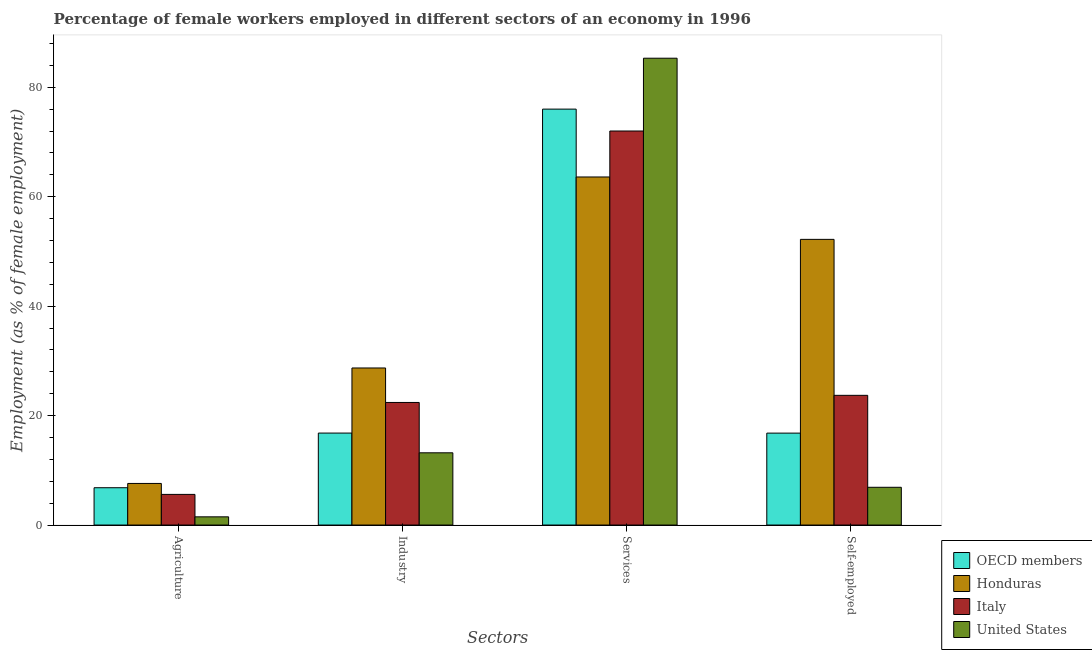Are the number of bars per tick equal to the number of legend labels?
Your answer should be very brief. Yes. How many bars are there on the 1st tick from the left?
Keep it short and to the point. 4. How many bars are there on the 1st tick from the right?
Provide a short and direct response. 4. What is the label of the 4th group of bars from the left?
Keep it short and to the point. Self-employed. What is the percentage of female workers in industry in Italy?
Offer a very short reply. 22.4. Across all countries, what is the maximum percentage of female workers in services?
Keep it short and to the point. 85.3. Across all countries, what is the minimum percentage of female workers in agriculture?
Your response must be concise. 1.5. In which country was the percentage of female workers in industry maximum?
Ensure brevity in your answer.  Honduras. What is the total percentage of female workers in industry in the graph?
Your answer should be compact. 81.1. What is the difference between the percentage of female workers in services in United States and that in Italy?
Offer a very short reply. 13.3. What is the difference between the percentage of female workers in services in Italy and the percentage of female workers in agriculture in OECD members?
Make the answer very short. 65.18. What is the average percentage of self employed female workers per country?
Your response must be concise. 24.9. What is the difference between the percentage of female workers in agriculture and percentage of female workers in industry in Honduras?
Your response must be concise. -21.1. What is the ratio of the percentage of female workers in services in Honduras to that in United States?
Your answer should be compact. 0.75. Is the percentage of self employed female workers in Italy less than that in Honduras?
Ensure brevity in your answer.  Yes. Is the difference between the percentage of female workers in industry in Honduras and United States greater than the difference between the percentage of female workers in agriculture in Honduras and United States?
Your answer should be very brief. Yes. What is the difference between the highest and the second highest percentage of female workers in agriculture?
Provide a succinct answer. 0.78. What is the difference between the highest and the lowest percentage of female workers in agriculture?
Give a very brief answer. 6.1. In how many countries, is the percentage of female workers in services greater than the average percentage of female workers in services taken over all countries?
Provide a succinct answer. 2. Is the sum of the percentage of female workers in services in Italy and Honduras greater than the maximum percentage of self employed female workers across all countries?
Your answer should be compact. Yes. Is it the case that in every country, the sum of the percentage of female workers in agriculture and percentage of female workers in industry is greater than the sum of percentage of self employed female workers and percentage of female workers in services?
Make the answer very short. Yes. What does the 3rd bar from the right in Agriculture represents?
Keep it short and to the point. Honduras. Are all the bars in the graph horizontal?
Your answer should be very brief. No. What is the difference between two consecutive major ticks on the Y-axis?
Your answer should be compact. 20. Does the graph contain any zero values?
Provide a short and direct response. No. Where does the legend appear in the graph?
Offer a very short reply. Bottom right. How many legend labels are there?
Your answer should be very brief. 4. How are the legend labels stacked?
Ensure brevity in your answer.  Vertical. What is the title of the graph?
Ensure brevity in your answer.  Percentage of female workers employed in different sectors of an economy in 1996. Does "Moldova" appear as one of the legend labels in the graph?
Give a very brief answer. No. What is the label or title of the X-axis?
Your answer should be very brief. Sectors. What is the label or title of the Y-axis?
Your answer should be compact. Employment (as % of female employment). What is the Employment (as % of female employment) in OECD members in Agriculture?
Your response must be concise. 6.82. What is the Employment (as % of female employment) in Honduras in Agriculture?
Ensure brevity in your answer.  7.6. What is the Employment (as % of female employment) in Italy in Agriculture?
Your response must be concise. 5.6. What is the Employment (as % of female employment) of United States in Agriculture?
Offer a very short reply. 1.5. What is the Employment (as % of female employment) of OECD members in Industry?
Your answer should be very brief. 16.8. What is the Employment (as % of female employment) of Honduras in Industry?
Offer a terse response. 28.7. What is the Employment (as % of female employment) of Italy in Industry?
Your answer should be very brief. 22.4. What is the Employment (as % of female employment) in United States in Industry?
Your answer should be compact. 13.2. What is the Employment (as % of female employment) of OECD members in Services?
Offer a terse response. 76. What is the Employment (as % of female employment) of Honduras in Services?
Provide a succinct answer. 63.6. What is the Employment (as % of female employment) in United States in Services?
Your answer should be compact. 85.3. What is the Employment (as % of female employment) of OECD members in Self-employed?
Keep it short and to the point. 16.8. What is the Employment (as % of female employment) of Honduras in Self-employed?
Give a very brief answer. 52.2. What is the Employment (as % of female employment) of Italy in Self-employed?
Ensure brevity in your answer.  23.7. What is the Employment (as % of female employment) in United States in Self-employed?
Provide a succinct answer. 6.9. Across all Sectors, what is the maximum Employment (as % of female employment) of OECD members?
Offer a very short reply. 76. Across all Sectors, what is the maximum Employment (as % of female employment) of Honduras?
Give a very brief answer. 63.6. Across all Sectors, what is the maximum Employment (as % of female employment) of United States?
Your response must be concise. 85.3. Across all Sectors, what is the minimum Employment (as % of female employment) in OECD members?
Make the answer very short. 6.82. Across all Sectors, what is the minimum Employment (as % of female employment) of Honduras?
Give a very brief answer. 7.6. Across all Sectors, what is the minimum Employment (as % of female employment) in Italy?
Ensure brevity in your answer.  5.6. Across all Sectors, what is the minimum Employment (as % of female employment) in United States?
Your response must be concise. 1.5. What is the total Employment (as % of female employment) of OECD members in the graph?
Offer a terse response. 116.42. What is the total Employment (as % of female employment) of Honduras in the graph?
Your answer should be very brief. 152.1. What is the total Employment (as % of female employment) in Italy in the graph?
Your answer should be very brief. 123.7. What is the total Employment (as % of female employment) in United States in the graph?
Your answer should be compact. 106.9. What is the difference between the Employment (as % of female employment) of OECD members in Agriculture and that in Industry?
Your response must be concise. -9.99. What is the difference between the Employment (as % of female employment) in Honduras in Agriculture and that in Industry?
Offer a terse response. -21.1. What is the difference between the Employment (as % of female employment) of Italy in Agriculture and that in Industry?
Ensure brevity in your answer.  -16.8. What is the difference between the Employment (as % of female employment) in OECD members in Agriculture and that in Services?
Make the answer very short. -69.18. What is the difference between the Employment (as % of female employment) of Honduras in Agriculture and that in Services?
Your answer should be compact. -56. What is the difference between the Employment (as % of female employment) in Italy in Agriculture and that in Services?
Offer a terse response. -66.4. What is the difference between the Employment (as % of female employment) in United States in Agriculture and that in Services?
Your response must be concise. -83.8. What is the difference between the Employment (as % of female employment) of OECD members in Agriculture and that in Self-employed?
Your response must be concise. -9.98. What is the difference between the Employment (as % of female employment) of Honduras in Agriculture and that in Self-employed?
Offer a very short reply. -44.6. What is the difference between the Employment (as % of female employment) in Italy in Agriculture and that in Self-employed?
Your response must be concise. -18.1. What is the difference between the Employment (as % of female employment) of United States in Agriculture and that in Self-employed?
Your answer should be very brief. -5.4. What is the difference between the Employment (as % of female employment) in OECD members in Industry and that in Services?
Provide a succinct answer. -59.2. What is the difference between the Employment (as % of female employment) in Honduras in Industry and that in Services?
Keep it short and to the point. -34.9. What is the difference between the Employment (as % of female employment) of Italy in Industry and that in Services?
Offer a terse response. -49.6. What is the difference between the Employment (as % of female employment) of United States in Industry and that in Services?
Give a very brief answer. -72.1. What is the difference between the Employment (as % of female employment) in OECD members in Industry and that in Self-employed?
Your answer should be compact. 0.01. What is the difference between the Employment (as % of female employment) of Honduras in Industry and that in Self-employed?
Offer a very short reply. -23.5. What is the difference between the Employment (as % of female employment) of OECD members in Services and that in Self-employed?
Provide a short and direct response. 59.2. What is the difference between the Employment (as % of female employment) of Italy in Services and that in Self-employed?
Offer a very short reply. 48.3. What is the difference between the Employment (as % of female employment) of United States in Services and that in Self-employed?
Your answer should be very brief. 78.4. What is the difference between the Employment (as % of female employment) in OECD members in Agriculture and the Employment (as % of female employment) in Honduras in Industry?
Provide a succinct answer. -21.88. What is the difference between the Employment (as % of female employment) in OECD members in Agriculture and the Employment (as % of female employment) in Italy in Industry?
Ensure brevity in your answer.  -15.58. What is the difference between the Employment (as % of female employment) of OECD members in Agriculture and the Employment (as % of female employment) of United States in Industry?
Ensure brevity in your answer.  -6.38. What is the difference between the Employment (as % of female employment) in Honduras in Agriculture and the Employment (as % of female employment) in Italy in Industry?
Provide a succinct answer. -14.8. What is the difference between the Employment (as % of female employment) in Italy in Agriculture and the Employment (as % of female employment) in United States in Industry?
Provide a succinct answer. -7.6. What is the difference between the Employment (as % of female employment) of OECD members in Agriculture and the Employment (as % of female employment) of Honduras in Services?
Provide a short and direct response. -56.78. What is the difference between the Employment (as % of female employment) of OECD members in Agriculture and the Employment (as % of female employment) of Italy in Services?
Offer a very short reply. -65.18. What is the difference between the Employment (as % of female employment) of OECD members in Agriculture and the Employment (as % of female employment) of United States in Services?
Make the answer very short. -78.48. What is the difference between the Employment (as % of female employment) of Honduras in Agriculture and the Employment (as % of female employment) of Italy in Services?
Your answer should be very brief. -64.4. What is the difference between the Employment (as % of female employment) of Honduras in Agriculture and the Employment (as % of female employment) of United States in Services?
Your answer should be compact. -77.7. What is the difference between the Employment (as % of female employment) of Italy in Agriculture and the Employment (as % of female employment) of United States in Services?
Provide a short and direct response. -79.7. What is the difference between the Employment (as % of female employment) of OECD members in Agriculture and the Employment (as % of female employment) of Honduras in Self-employed?
Your answer should be compact. -45.38. What is the difference between the Employment (as % of female employment) in OECD members in Agriculture and the Employment (as % of female employment) in Italy in Self-employed?
Offer a terse response. -16.88. What is the difference between the Employment (as % of female employment) of OECD members in Agriculture and the Employment (as % of female employment) of United States in Self-employed?
Keep it short and to the point. -0.08. What is the difference between the Employment (as % of female employment) in Honduras in Agriculture and the Employment (as % of female employment) in Italy in Self-employed?
Give a very brief answer. -16.1. What is the difference between the Employment (as % of female employment) in Honduras in Agriculture and the Employment (as % of female employment) in United States in Self-employed?
Offer a terse response. 0.7. What is the difference between the Employment (as % of female employment) of OECD members in Industry and the Employment (as % of female employment) of Honduras in Services?
Your answer should be very brief. -46.8. What is the difference between the Employment (as % of female employment) of OECD members in Industry and the Employment (as % of female employment) of Italy in Services?
Your response must be concise. -55.2. What is the difference between the Employment (as % of female employment) in OECD members in Industry and the Employment (as % of female employment) in United States in Services?
Ensure brevity in your answer.  -68.5. What is the difference between the Employment (as % of female employment) in Honduras in Industry and the Employment (as % of female employment) in Italy in Services?
Give a very brief answer. -43.3. What is the difference between the Employment (as % of female employment) in Honduras in Industry and the Employment (as % of female employment) in United States in Services?
Provide a succinct answer. -56.6. What is the difference between the Employment (as % of female employment) of Italy in Industry and the Employment (as % of female employment) of United States in Services?
Your answer should be very brief. -62.9. What is the difference between the Employment (as % of female employment) of OECD members in Industry and the Employment (as % of female employment) of Honduras in Self-employed?
Provide a short and direct response. -35.4. What is the difference between the Employment (as % of female employment) of OECD members in Industry and the Employment (as % of female employment) of Italy in Self-employed?
Ensure brevity in your answer.  -6.9. What is the difference between the Employment (as % of female employment) in OECD members in Industry and the Employment (as % of female employment) in United States in Self-employed?
Ensure brevity in your answer.  9.9. What is the difference between the Employment (as % of female employment) of Honduras in Industry and the Employment (as % of female employment) of Italy in Self-employed?
Your answer should be compact. 5. What is the difference between the Employment (as % of female employment) of Honduras in Industry and the Employment (as % of female employment) of United States in Self-employed?
Give a very brief answer. 21.8. What is the difference between the Employment (as % of female employment) in OECD members in Services and the Employment (as % of female employment) in Honduras in Self-employed?
Your answer should be very brief. 23.8. What is the difference between the Employment (as % of female employment) of OECD members in Services and the Employment (as % of female employment) of Italy in Self-employed?
Give a very brief answer. 52.3. What is the difference between the Employment (as % of female employment) in OECD members in Services and the Employment (as % of female employment) in United States in Self-employed?
Your response must be concise. 69.1. What is the difference between the Employment (as % of female employment) in Honduras in Services and the Employment (as % of female employment) in Italy in Self-employed?
Offer a very short reply. 39.9. What is the difference between the Employment (as % of female employment) in Honduras in Services and the Employment (as % of female employment) in United States in Self-employed?
Provide a succinct answer. 56.7. What is the difference between the Employment (as % of female employment) of Italy in Services and the Employment (as % of female employment) of United States in Self-employed?
Give a very brief answer. 65.1. What is the average Employment (as % of female employment) in OECD members per Sectors?
Offer a very short reply. 29.11. What is the average Employment (as % of female employment) of Honduras per Sectors?
Make the answer very short. 38.02. What is the average Employment (as % of female employment) of Italy per Sectors?
Provide a short and direct response. 30.93. What is the average Employment (as % of female employment) of United States per Sectors?
Keep it short and to the point. 26.73. What is the difference between the Employment (as % of female employment) in OECD members and Employment (as % of female employment) in Honduras in Agriculture?
Keep it short and to the point. -0.78. What is the difference between the Employment (as % of female employment) of OECD members and Employment (as % of female employment) of Italy in Agriculture?
Your answer should be very brief. 1.22. What is the difference between the Employment (as % of female employment) in OECD members and Employment (as % of female employment) in United States in Agriculture?
Make the answer very short. 5.32. What is the difference between the Employment (as % of female employment) of Honduras and Employment (as % of female employment) of Italy in Agriculture?
Make the answer very short. 2. What is the difference between the Employment (as % of female employment) in Honduras and Employment (as % of female employment) in United States in Agriculture?
Offer a very short reply. 6.1. What is the difference between the Employment (as % of female employment) of OECD members and Employment (as % of female employment) of Honduras in Industry?
Offer a terse response. -11.9. What is the difference between the Employment (as % of female employment) in OECD members and Employment (as % of female employment) in Italy in Industry?
Keep it short and to the point. -5.6. What is the difference between the Employment (as % of female employment) in OECD members and Employment (as % of female employment) in United States in Industry?
Provide a succinct answer. 3.6. What is the difference between the Employment (as % of female employment) in Honduras and Employment (as % of female employment) in Italy in Industry?
Your answer should be very brief. 6.3. What is the difference between the Employment (as % of female employment) in Honduras and Employment (as % of female employment) in United States in Industry?
Make the answer very short. 15.5. What is the difference between the Employment (as % of female employment) of Italy and Employment (as % of female employment) of United States in Industry?
Keep it short and to the point. 9.2. What is the difference between the Employment (as % of female employment) of OECD members and Employment (as % of female employment) of Honduras in Services?
Keep it short and to the point. 12.4. What is the difference between the Employment (as % of female employment) in OECD members and Employment (as % of female employment) in Italy in Services?
Offer a very short reply. 4. What is the difference between the Employment (as % of female employment) in OECD members and Employment (as % of female employment) in United States in Services?
Ensure brevity in your answer.  -9.3. What is the difference between the Employment (as % of female employment) of Honduras and Employment (as % of female employment) of United States in Services?
Ensure brevity in your answer.  -21.7. What is the difference between the Employment (as % of female employment) of Italy and Employment (as % of female employment) of United States in Services?
Keep it short and to the point. -13.3. What is the difference between the Employment (as % of female employment) in OECD members and Employment (as % of female employment) in Honduras in Self-employed?
Offer a very short reply. -35.4. What is the difference between the Employment (as % of female employment) of OECD members and Employment (as % of female employment) of Italy in Self-employed?
Give a very brief answer. -6.9. What is the difference between the Employment (as % of female employment) in OECD members and Employment (as % of female employment) in United States in Self-employed?
Make the answer very short. 9.9. What is the difference between the Employment (as % of female employment) in Honduras and Employment (as % of female employment) in United States in Self-employed?
Your answer should be compact. 45.3. What is the difference between the Employment (as % of female employment) in Italy and Employment (as % of female employment) in United States in Self-employed?
Make the answer very short. 16.8. What is the ratio of the Employment (as % of female employment) of OECD members in Agriculture to that in Industry?
Offer a very short reply. 0.41. What is the ratio of the Employment (as % of female employment) in Honduras in Agriculture to that in Industry?
Keep it short and to the point. 0.26. What is the ratio of the Employment (as % of female employment) of Italy in Agriculture to that in Industry?
Your response must be concise. 0.25. What is the ratio of the Employment (as % of female employment) in United States in Agriculture to that in Industry?
Offer a very short reply. 0.11. What is the ratio of the Employment (as % of female employment) of OECD members in Agriculture to that in Services?
Make the answer very short. 0.09. What is the ratio of the Employment (as % of female employment) in Honduras in Agriculture to that in Services?
Offer a terse response. 0.12. What is the ratio of the Employment (as % of female employment) of Italy in Agriculture to that in Services?
Offer a very short reply. 0.08. What is the ratio of the Employment (as % of female employment) in United States in Agriculture to that in Services?
Your answer should be very brief. 0.02. What is the ratio of the Employment (as % of female employment) of OECD members in Agriculture to that in Self-employed?
Keep it short and to the point. 0.41. What is the ratio of the Employment (as % of female employment) of Honduras in Agriculture to that in Self-employed?
Provide a short and direct response. 0.15. What is the ratio of the Employment (as % of female employment) of Italy in Agriculture to that in Self-employed?
Ensure brevity in your answer.  0.24. What is the ratio of the Employment (as % of female employment) of United States in Agriculture to that in Self-employed?
Ensure brevity in your answer.  0.22. What is the ratio of the Employment (as % of female employment) in OECD members in Industry to that in Services?
Offer a terse response. 0.22. What is the ratio of the Employment (as % of female employment) in Honduras in Industry to that in Services?
Ensure brevity in your answer.  0.45. What is the ratio of the Employment (as % of female employment) of Italy in Industry to that in Services?
Your answer should be compact. 0.31. What is the ratio of the Employment (as % of female employment) of United States in Industry to that in Services?
Your answer should be compact. 0.15. What is the ratio of the Employment (as % of female employment) in Honduras in Industry to that in Self-employed?
Provide a succinct answer. 0.55. What is the ratio of the Employment (as % of female employment) in Italy in Industry to that in Self-employed?
Keep it short and to the point. 0.95. What is the ratio of the Employment (as % of female employment) in United States in Industry to that in Self-employed?
Offer a very short reply. 1.91. What is the ratio of the Employment (as % of female employment) in OECD members in Services to that in Self-employed?
Offer a terse response. 4.52. What is the ratio of the Employment (as % of female employment) in Honduras in Services to that in Self-employed?
Offer a very short reply. 1.22. What is the ratio of the Employment (as % of female employment) of Italy in Services to that in Self-employed?
Provide a succinct answer. 3.04. What is the ratio of the Employment (as % of female employment) in United States in Services to that in Self-employed?
Your answer should be very brief. 12.36. What is the difference between the highest and the second highest Employment (as % of female employment) in OECD members?
Your response must be concise. 59.2. What is the difference between the highest and the second highest Employment (as % of female employment) of Honduras?
Ensure brevity in your answer.  11.4. What is the difference between the highest and the second highest Employment (as % of female employment) of Italy?
Ensure brevity in your answer.  48.3. What is the difference between the highest and the second highest Employment (as % of female employment) in United States?
Your response must be concise. 72.1. What is the difference between the highest and the lowest Employment (as % of female employment) of OECD members?
Your response must be concise. 69.18. What is the difference between the highest and the lowest Employment (as % of female employment) of Honduras?
Your answer should be very brief. 56. What is the difference between the highest and the lowest Employment (as % of female employment) in Italy?
Provide a succinct answer. 66.4. What is the difference between the highest and the lowest Employment (as % of female employment) in United States?
Keep it short and to the point. 83.8. 